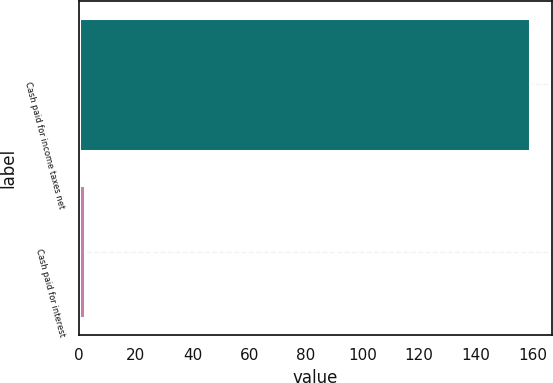Convert chart to OTSL. <chart><loc_0><loc_0><loc_500><loc_500><bar_chart><fcel>Cash paid for income taxes net<fcel>Cash paid for interest<nl><fcel>159<fcel>2<nl></chart> 